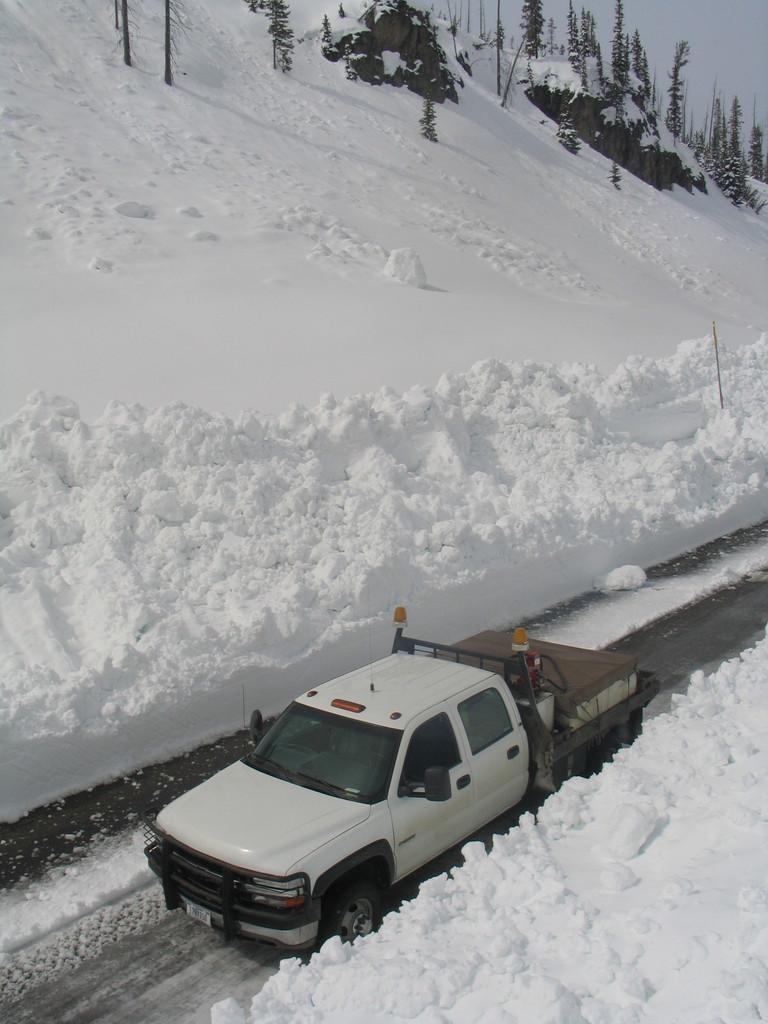Could you give a brief overview of what you see in this image? In this image we can see a vehicle and objects in the truck on the road. To either side of the road we can see snow. In the background we can see trees, pole, rocks and sky. 